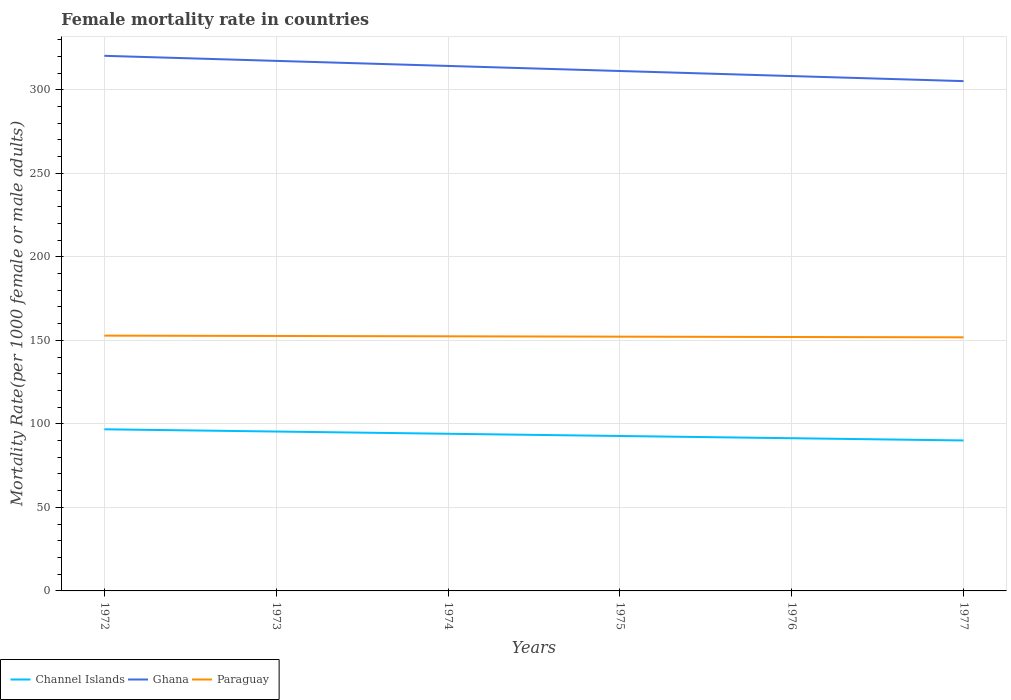Across all years, what is the maximum female mortality rate in Paraguay?
Offer a terse response. 151.8. In which year was the female mortality rate in Paraguay maximum?
Provide a short and direct response. 1977. What is the total female mortality rate in Paraguay in the graph?
Your response must be concise. 0.61. What is the difference between the highest and the second highest female mortality rate in Paraguay?
Offer a terse response. 1.02. What is the difference between the highest and the lowest female mortality rate in Channel Islands?
Provide a succinct answer. 3. How many years are there in the graph?
Provide a succinct answer. 6. How many legend labels are there?
Make the answer very short. 3. How are the legend labels stacked?
Offer a terse response. Horizontal. What is the title of the graph?
Offer a very short reply. Female mortality rate in countries. What is the label or title of the X-axis?
Provide a short and direct response. Years. What is the label or title of the Y-axis?
Keep it short and to the point. Mortality Rate(per 1000 female or male adults). What is the Mortality Rate(per 1000 female or male adults) in Channel Islands in 1972?
Offer a terse response. 96.75. What is the Mortality Rate(per 1000 female or male adults) of Ghana in 1972?
Provide a succinct answer. 320.33. What is the Mortality Rate(per 1000 female or male adults) in Paraguay in 1972?
Keep it short and to the point. 152.82. What is the Mortality Rate(per 1000 female or male adults) of Channel Islands in 1973?
Ensure brevity in your answer.  95.42. What is the Mortality Rate(per 1000 female or male adults) in Ghana in 1973?
Give a very brief answer. 317.3. What is the Mortality Rate(per 1000 female or male adults) in Paraguay in 1973?
Your response must be concise. 152.62. What is the Mortality Rate(per 1000 female or male adults) of Channel Islands in 1974?
Your answer should be very brief. 94.08. What is the Mortality Rate(per 1000 female or male adults) in Ghana in 1974?
Ensure brevity in your answer.  314.27. What is the Mortality Rate(per 1000 female or male adults) of Paraguay in 1974?
Make the answer very short. 152.42. What is the Mortality Rate(per 1000 female or male adults) in Channel Islands in 1975?
Make the answer very short. 92.75. What is the Mortality Rate(per 1000 female or male adults) of Ghana in 1975?
Your response must be concise. 311.24. What is the Mortality Rate(per 1000 female or male adults) of Paraguay in 1975?
Provide a succinct answer. 152.21. What is the Mortality Rate(per 1000 female or male adults) of Channel Islands in 1976?
Ensure brevity in your answer.  91.41. What is the Mortality Rate(per 1000 female or male adults) of Ghana in 1976?
Your answer should be compact. 308.21. What is the Mortality Rate(per 1000 female or male adults) of Paraguay in 1976?
Offer a very short reply. 152.01. What is the Mortality Rate(per 1000 female or male adults) in Channel Islands in 1977?
Make the answer very short. 90.08. What is the Mortality Rate(per 1000 female or male adults) in Ghana in 1977?
Make the answer very short. 305.18. What is the Mortality Rate(per 1000 female or male adults) in Paraguay in 1977?
Your response must be concise. 151.8. Across all years, what is the maximum Mortality Rate(per 1000 female or male adults) of Channel Islands?
Ensure brevity in your answer.  96.75. Across all years, what is the maximum Mortality Rate(per 1000 female or male adults) of Ghana?
Your answer should be compact. 320.33. Across all years, what is the maximum Mortality Rate(per 1000 female or male adults) in Paraguay?
Your answer should be compact. 152.82. Across all years, what is the minimum Mortality Rate(per 1000 female or male adults) in Channel Islands?
Offer a very short reply. 90.08. Across all years, what is the minimum Mortality Rate(per 1000 female or male adults) of Ghana?
Provide a short and direct response. 305.18. Across all years, what is the minimum Mortality Rate(per 1000 female or male adults) of Paraguay?
Offer a very short reply. 151.8. What is the total Mortality Rate(per 1000 female or male adults) of Channel Islands in the graph?
Your answer should be very brief. 560.48. What is the total Mortality Rate(per 1000 female or male adults) in Ghana in the graph?
Offer a very short reply. 1876.54. What is the total Mortality Rate(per 1000 female or male adults) in Paraguay in the graph?
Make the answer very short. 913.88. What is the difference between the Mortality Rate(per 1000 female or male adults) in Channel Islands in 1972 and that in 1973?
Make the answer very short. 1.33. What is the difference between the Mortality Rate(per 1000 female or male adults) of Ghana in 1972 and that in 1973?
Offer a terse response. 3.03. What is the difference between the Mortality Rate(per 1000 female or male adults) in Paraguay in 1972 and that in 1973?
Make the answer very short. 0.2. What is the difference between the Mortality Rate(per 1000 female or male adults) of Channel Islands in 1972 and that in 1974?
Offer a terse response. 2.67. What is the difference between the Mortality Rate(per 1000 female or male adults) of Ghana in 1972 and that in 1974?
Your answer should be compact. 6.06. What is the difference between the Mortality Rate(per 1000 female or male adults) of Paraguay in 1972 and that in 1974?
Your response must be concise. 0.41. What is the difference between the Mortality Rate(per 1000 female or male adults) of Channel Islands in 1972 and that in 1975?
Make the answer very short. 4. What is the difference between the Mortality Rate(per 1000 female or male adults) of Ghana in 1972 and that in 1975?
Provide a short and direct response. 9.09. What is the difference between the Mortality Rate(per 1000 female or male adults) of Paraguay in 1972 and that in 1975?
Your answer should be compact. 0.61. What is the difference between the Mortality Rate(per 1000 female or male adults) in Channel Islands in 1972 and that in 1976?
Offer a terse response. 5.34. What is the difference between the Mortality Rate(per 1000 female or male adults) in Ghana in 1972 and that in 1976?
Make the answer very short. 12.12. What is the difference between the Mortality Rate(per 1000 female or male adults) of Paraguay in 1972 and that in 1976?
Offer a very short reply. 0.82. What is the difference between the Mortality Rate(per 1000 female or male adults) in Channel Islands in 1972 and that in 1977?
Your answer should be very brief. 6.67. What is the difference between the Mortality Rate(per 1000 female or male adults) of Ghana in 1972 and that in 1977?
Give a very brief answer. 15.15. What is the difference between the Mortality Rate(per 1000 female or male adults) of Paraguay in 1972 and that in 1977?
Ensure brevity in your answer.  1.02. What is the difference between the Mortality Rate(per 1000 female or male adults) in Channel Islands in 1973 and that in 1974?
Your answer should be compact. 1.33. What is the difference between the Mortality Rate(per 1000 female or male adults) in Ghana in 1973 and that in 1974?
Your answer should be compact. 3.03. What is the difference between the Mortality Rate(per 1000 female or male adults) in Paraguay in 1973 and that in 1974?
Offer a very short reply. 0.2. What is the difference between the Mortality Rate(per 1000 female or male adults) of Channel Islands in 1973 and that in 1975?
Ensure brevity in your answer.  2.67. What is the difference between the Mortality Rate(per 1000 female or male adults) in Ghana in 1973 and that in 1975?
Keep it short and to the point. 6.06. What is the difference between the Mortality Rate(per 1000 female or male adults) of Paraguay in 1973 and that in 1975?
Give a very brief answer. 0.41. What is the difference between the Mortality Rate(per 1000 female or male adults) of Channel Islands in 1973 and that in 1976?
Provide a succinct answer. 4. What is the difference between the Mortality Rate(per 1000 female or male adults) of Ghana in 1973 and that in 1976?
Give a very brief answer. 9.09. What is the difference between the Mortality Rate(per 1000 female or male adults) of Paraguay in 1973 and that in 1976?
Provide a short and direct response. 0.61. What is the difference between the Mortality Rate(per 1000 female or male adults) in Channel Islands in 1973 and that in 1977?
Offer a very short reply. 5.34. What is the difference between the Mortality Rate(per 1000 female or male adults) in Ghana in 1973 and that in 1977?
Make the answer very short. 12.12. What is the difference between the Mortality Rate(per 1000 female or male adults) in Paraguay in 1973 and that in 1977?
Ensure brevity in your answer.  0.82. What is the difference between the Mortality Rate(per 1000 female or male adults) in Channel Islands in 1974 and that in 1975?
Give a very brief answer. 1.33. What is the difference between the Mortality Rate(per 1000 female or male adults) in Ghana in 1974 and that in 1975?
Make the answer very short. 3.03. What is the difference between the Mortality Rate(per 1000 female or male adults) in Paraguay in 1974 and that in 1975?
Your response must be concise. 0.2. What is the difference between the Mortality Rate(per 1000 female or male adults) of Channel Islands in 1974 and that in 1976?
Your answer should be compact. 2.67. What is the difference between the Mortality Rate(per 1000 female or male adults) in Ghana in 1974 and that in 1976?
Your answer should be compact. 6.06. What is the difference between the Mortality Rate(per 1000 female or male adults) of Paraguay in 1974 and that in 1976?
Your response must be concise. 0.41. What is the difference between the Mortality Rate(per 1000 female or male adults) in Channel Islands in 1974 and that in 1977?
Make the answer very short. 4. What is the difference between the Mortality Rate(per 1000 female or male adults) in Ghana in 1974 and that in 1977?
Keep it short and to the point. 9.09. What is the difference between the Mortality Rate(per 1000 female or male adults) of Paraguay in 1974 and that in 1977?
Provide a succinct answer. 0.61. What is the difference between the Mortality Rate(per 1000 female or male adults) of Channel Islands in 1975 and that in 1976?
Ensure brevity in your answer.  1.33. What is the difference between the Mortality Rate(per 1000 female or male adults) in Ghana in 1975 and that in 1976?
Give a very brief answer. 3.03. What is the difference between the Mortality Rate(per 1000 female or male adults) of Paraguay in 1975 and that in 1976?
Offer a very short reply. 0.2. What is the difference between the Mortality Rate(per 1000 female or male adults) in Channel Islands in 1975 and that in 1977?
Provide a short and direct response. 2.67. What is the difference between the Mortality Rate(per 1000 female or male adults) in Ghana in 1975 and that in 1977?
Offer a terse response. 6.06. What is the difference between the Mortality Rate(per 1000 female or male adults) in Paraguay in 1975 and that in 1977?
Provide a succinct answer. 0.41. What is the difference between the Mortality Rate(per 1000 female or male adults) in Channel Islands in 1976 and that in 1977?
Provide a succinct answer. 1.33. What is the difference between the Mortality Rate(per 1000 female or male adults) in Ghana in 1976 and that in 1977?
Keep it short and to the point. 3.03. What is the difference between the Mortality Rate(per 1000 female or male adults) of Paraguay in 1976 and that in 1977?
Ensure brevity in your answer.  0.2. What is the difference between the Mortality Rate(per 1000 female or male adults) in Channel Islands in 1972 and the Mortality Rate(per 1000 female or male adults) in Ghana in 1973?
Your response must be concise. -220.55. What is the difference between the Mortality Rate(per 1000 female or male adults) of Channel Islands in 1972 and the Mortality Rate(per 1000 female or male adults) of Paraguay in 1973?
Your response must be concise. -55.87. What is the difference between the Mortality Rate(per 1000 female or male adults) of Ghana in 1972 and the Mortality Rate(per 1000 female or male adults) of Paraguay in 1973?
Your answer should be very brief. 167.71. What is the difference between the Mortality Rate(per 1000 female or male adults) in Channel Islands in 1972 and the Mortality Rate(per 1000 female or male adults) in Ghana in 1974?
Ensure brevity in your answer.  -217.52. What is the difference between the Mortality Rate(per 1000 female or male adults) of Channel Islands in 1972 and the Mortality Rate(per 1000 female or male adults) of Paraguay in 1974?
Make the answer very short. -55.67. What is the difference between the Mortality Rate(per 1000 female or male adults) of Ghana in 1972 and the Mortality Rate(per 1000 female or male adults) of Paraguay in 1974?
Ensure brevity in your answer.  167.92. What is the difference between the Mortality Rate(per 1000 female or male adults) of Channel Islands in 1972 and the Mortality Rate(per 1000 female or male adults) of Ghana in 1975?
Provide a succinct answer. -214.49. What is the difference between the Mortality Rate(per 1000 female or male adults) of Channel Islands in 1972 and the Mortality Rate(per 1000 female or male adults) of Paraguay in 1975?
Ensure brevity in your answer.  -55.46. What is the difference between the Mortality Rate(per 1000 female or male adults) of Ghana in 1972 and the Mortality Rate(per 1000 female or male adults) of Paraguay in 1975?
Provide a short and direct response. 168.12. What is the difference between the Mortality Rate(per 1000 female or male adults) of Channel Islands in 1972 and the Mortality Rate(per 1000 female or male adults) of Ghana in 1976?
Offer a terse response. -211.46. What is the difference between the Mortality Rate(per 1000 female or male adults) of Channel Islands in 1972 and the Mortality Rate(per 1000 female or male adults) of Paraguay in 1976?
Ensure brevity in your answer.  -55.26. What is the difference between the Mortality Rate(per 1000 female or male adults) in Ghana in 1972 and the Mortality Rate(per 1000 female or male adults) in Paraguay in 1976?
Your response must be concise. 168.33. What is the difference between the Mortality Rate(per 1000 female or male adults) of Channel Islands in 1972 and the Mortality Rate(per 1000 female or male adults) of Ghana in 1977?
Offer a terse response. -208.43. What is the difference between the Mortality Rate(per 1000 female or male adults) of Channel Islands in 1972 and the Mortality Rate(per 1000 female or male adults) of Paraguay in 1977?
Make the answer very short. -55.05. What is the difference between the Mortality Rate(per 1000 female or male adults) of Ghana in 1972 and the Mortality Rate(per 1000 female or male adults) of Paraguay in 1977?
Offer a terse response. 168.53. What is the difference between the Mortality Rate(per 1000 female or male adults) in Channel Islands in 1973 and the Mortality Rate(per 1000 female or male adults) in Ghana in 1974?
Offer a terse response. -218.86. What is the difference between the Mortality Rate(per 1000 female or male adults) of Channel Islands in 1973 and the Mortality Rate(per 1000 female or male adults) of Paraguay in 1974?
Your response must be concise. -57. What is the difference between the Mortality Rate(per 1000 female or male adults) in Ghana in 1973 and the Mortality Rate(per 1000 female or male adults) in Paraguay in 1974?
Offer a terse response. 164.89. What is the difference between the Mortality Rate(per 1000 female or male adults) in Channel Islands in 1973 and the Mortality Rate(per 1000 female or male adults) in Ghana in 1975?
Give a very brief answer. -215.83. What is the difference between the Mortality Rate(per 1000 female or male adults) of Channel Islands in 1973 and the Mortality Rate(per 1000 female or male adults) of Paraguay in 1975?
Your answer should be compact. -56.8. What is the difference between the Mortality Rate(per 1000 female or male adults) in Ghana in 1973 and the Mortality Rate(per 1000 female or male adults) in Paraguay in 1975?
Your answer should be very brief. 165.09. What is the difference between the Mortality Rate(per 1000 female or male adults) in Channel Islands in 1973 and the Mortality Rate(per 1000 female or male adults) in Ghana in 1976?
Make the answer very short. -212.8. What is the difference between the Mortality Rate(per 1000 female or male adults) in Channel Islands in 1973 and the Mortality Rate(per 1000 female or male adults) in Paraguay in 1976?
Your response must be concise. -56.59. What is the difference between the Mortality Rate(per 1000 female or male adults) in Ghana in 1973 and the Mortality Rate(per 1000 female or male adults) in Paraguay in 1976?
Your answer should be compact. 165.3. What is the difference between the Mortality Rate(per 1000 female or male adults) of Channel Islands in 1973 and the Mortality Rate(per 1000 female or male adults) of Ghana in 1977?
Offer a terse response. -209.76. What is the difference between the Mortality Rate(per 1000 female or male adults) in Channel Islands in 1973 and the Mortality Rate(per 1000 female or male adults) in Paraguay in 1977?
Your response must be concise. -56.39. What is the difference between the Mortality Rate(per 1000 female or male adults) in Ghana in 1973 and the Mortality Rate(per 1000 female or male adults) in Paraguay in 1977?
Provide a short and direct response. 165.5. What is the difference between the Mortality Rate(per 1000 female or male adults) in Channel Islands in 1974 and the Mortality Rate(per 1000 female or male adults) in Ghana in 1975?
Provide a succinct answer. -217.16. What is the difference between the Mortality Rate(per 1000 female or male adults) in Channel Islands in 1974 and the Mortality Rate(per 1000 female or male adults) in Paraguay in 1975?
Ensure brevity in your answer.  -58.13. What is the difference between the Mortality Rate(per 1000 female or male adults) of Ghana in 1974 and the Mortality Rate(per 1000 female or male adults) of Paraguay in 1975?
Provide a succinct answer. 162.06. What is the difference between the Mortality Rate(per 1000 female or male adults) of Channel Islands in 1974 and the Mortality Rate(per 1000 female or male adults) of Ghana in 1976?
Your answer should be very brief. -214.13. What is the difference between the Mortality Rate(per 1000 female or male adults) in Channel Islands in 1974 and the Mortality Rate(per 1000 female or male adults) in Paraguay in 1976?
Your answer should be compact. -57.93. What is the difference between the Mortality Rate(per 1000 female or male adults) in Ghana in 1974 and the Mortality Rate(per 1000 female or male adults) in Paraguay in 1976?
Your response must be concise. 162.26. What is the difference between the Mortality Rate(per 1000 female or male adults) of Channel Islands in 1974 and the Mortality Rate(per 1000 female or male adults) of Ghana in 1977?
Make the answer very short. -211.1. What is the difference between the Mortality Rate(per 1000 female or male adults) in Channel Islands in 1974 and the Mortality Rate(per 1000 female or male adults) in Paraguay in 1977?
Make the answer very short. -57.72. What is the difference between the Mortality Rate(per 1000 female or male adults) in Ghana in 1974 and the Mortality Rate(per 1000 female or male adults) in Paraguay in 1977?
Ensure brevity in your answer.  162.47. What is the difference between the Mortality Rate(per 1000 female or male adults) in Channel Islands in 1975 and the Mortality Rate(per 1000 female or male adults) in Ghana in 1976?
Provide a short and direct response. -215.47. What is the difference between the Mortality Rate(per 1000 female or male adults) of Channel Islands in 1975 and the Mortality Rate(per 1000 female or male adults) of Paraguay in 1976?
Make the answer very short. -59.26. What is the difference between the Mortality Rate(per 1000 female or male adults) in Ghana in 1975 and the Mortality Rate(per 1000 female or male adults) in Paraguay in 1976?
Provide a succinct answer. 159.23. What is the difference between the Mortality Rate(per 1000 female or male adults) of Channel Islands in 1975 and the Mortality Rate(per 1000 female or male adults) of Ghana in 1977?
Ensure brevity in your answer.  -212.44. What is the difference between the Mortality Rate(per 1000 female or male adults) in Channel Islands in 1975 and the Mortality Rate(per 1000 female or male adults) in Paraguay in 1977?
Offer a terse response. -59.06. What is the difference between the Mortality Rate(per 1000 female or male adults) of Ghana in 1975 and the Mortality Rate(per 1000 female or male adults) of Paraguay in 1977?
Give a very brief answer. 159.44. What is the difference between the Mortality Rate(per 1000 female or male adults) in Channel Islands in 1976 and the Mortality Rate(per 1000 female or male adults) in Ghana in 1977?
Keep it short and to the point. -213.77. What is the difference between the Mortality Rate(per 1000 female or male adults) of Channel Islands in 1976 and the Mortality Rate(per 1000 female or male adults) of Paraguay in 1977?
Your answer should be very brief. -60.39. What is the difference between the Mortality Rate(per 1000 female or male adults) in Ghana in 1976 and the Mortality Rate(per 1000 female or male adults) in Paraguay in 1977?
Keep it short and to the point. 156.41. What is the average Mortality Rate(per 1000 female or male adults) in Channel Islands per year?
Your answer should be compact. 93.41. What is the average Mortality Rate(per 1000 female or male adults) of Ghana per year?
Ensure brevity in your answer.  312.76. What is the average Mortality Rate(per 1000 female or male adults) of Paraguay per year?
Ensure brevity in your answer.  152.31. In the year 1972, what is the difference between the Mortality Rate(per 1000 female or male adults) in Channel Islands and Mortality Rate(per 1000 female or male adults) in Ghana?
Keep it short and to the point. -223.58. In the year 1972, what is the difference between the Mortality Rate(per 1000 female or male adults) in Channel Islands and Mortality Rate(per 1000 female or male adults) in Paraguay?
Your answer should be compact. -56.07. In the year 1972, what is the difference between the Mortality Rate(per 1000 female or male adults) in Ghana and Mortality Rate(per 1000 female or male adults) in Paraguay?
Your answer should be compact. 167.51. In the year 1973, what is the difference between the Mortality Rate(per 1000 female or male adults) of Channel Islands and Mortality Rate(per 1000 female or male adults) of Ghana?
Provide a succinct answer. -221.89. In the year 1973, what is the difference between the Mortality Rate(per 1000 female or male adults) of Channel Islands and Mortality Rate(per 1000 female or male adults) of Paraguay?
Offer a very short reply. -57.2. In the year 1973, what is the difference between the Mortality Rate(per 1000 female or male adults) of Ghana and Mortality Rate(per 1000 female or male adults) of Paraguay?
Ensure brevity in your answer.  164.68. In the year 1974, what is the difference between the Mortality Rate(per 1000 female or male adults) in Channel Islands and Mortality Rate(per 1000 female or male adults) in Ghana?
Keep it short and to the point. -220.19. In the year 1974, what is the difference between the Mortality Rate(per 1000 female or male adults) in Channel Islands and Mortality Rate(per 1000 female or male adults) in Paraguay?
Provide a succinct answer. -58.34. In the year 1974, what is the difference between the Mortality Rate(per 1000 female or male adults) of Ghana and Mortality Rate(per 1000 female or male adults) of Paraguay?
Ensure brevity in your answer.  161.86. In the year 1975, what is the difference between the Mortality Rate(per 1000 female or male adults) in Channel Islands and Mortality Rate(per 1000 female or male adults) in Ghana?
Your answer should be very brief. -218.5. In the year 1975, what is the difference between the Mortality Rate(per 1000 female or male adults) of Channel Islands and Mortality Rate(per 1000 female or male adults) of Paraguay?
Your response must be concise. -59.47. In the year 1975, what is the difference between the Mortality Rate(per 1000 female or male adults) in Ghana and Mortality Rate(per 1000 female or male adults) in Paraguay?
Offer a very short reply. 159.03. In the year 1976, what is the difference between the Mortality Rate(per 1000 female or male adults) in Channel Islands and Mortality Rate(per 1000 female or male adults) in Ghana?
Provide a short and direct response. -216.8. In the year 1976, what is the difference between the Mortality Rate(per 1000 female or male adults) in Channel Islands and Mortality Rate(per 1000 female or male adults) in Paraguay?
Provide a short and direct response. -60.6. In the year 1976, what is the difference between the Mortality Rate(per 1000 female or male adults) in Ghana and Mortality Rate(per 1000 female or male adults) in Paraguay?
Your response must be concise. 156.2. In the year 1977, what is the difference between the Mortality Rate(per 1000 female or male adults) in Channel Islands and Mortality Rate(per 1000 female or male adults) in Ghana?
Make the answer very short. -215.1. In the year 1977, what is the difference between the Mortality Rate(per 1000 female or male adults) in Channel Islands and Mortality Rate(per 1000 female or male adults) in Paraguay?
Your answer should be very brief. -61.73. In the year 1977, what is the difference between the Mortality Rate(per 1000 female or male adults) of Ghana and Mortality Rate(per 1000 female or male adults) of Paraguay?
Your answer should be very brief. 153.38. What is the ratio of the Mortality Rate(per 1000 female or male adults) in Channel Islands in 1972 to that in 1973?
Offer a terse response. 1.01. What is the ratio of the Mortality Rate(per 1000 female or male adults) in Ghana in 1972 to that in 1973?
Give a very brief answer. 1.01. What is the ratio of the Mortality Rate(per 1000 female or male adults) of Channel Islands in 1972 to that in 1974?
Ensure brevity in your answer.  1.03. What is the ratio of the Mortality Rate(per 1000 female or male adults) of Ghana in 1972 to that in 1974?
Make the answer very short. 1.02. What is the ratio of the Mortality Rate(per 1000 female or male adults) in Paraguay in 1972 to that in 1974?
Offer a very short reply. 1. What is the ratio of the Mortality Rate(per 1000 female or male adults) of Channel Islands in 1972 to that in 1975?
Your response must be concise. 1.04. What is the ratio of the Mortality Rate(per 1000 female or male adults) in Ghana in 1972 to that in 1975?
Ensure brevity in your answer.  1.03. What is the ratio of the Mortality Rate(per 1000 female or male adults) in Paraguay in 1972 to that in 1975?
Offer a terse response. 1. What is the ratio of the Mortality Rate(per 1000 female or male adults) of Channel Islands in 1972 to that in 1976?
Your answer should be very brief. 1.06. What is the ratio of the Mortality Rate(per 1000 female or male adults) of Ghana in 1972 to that in 1976?
Keep it short and to the point. 1.04. What is the ratio of the Mortality Rate(per 1000 female or male adults) of Paraguay in 1972 to that in 1976?
Your answer should be very brief. 1.01. What is the ratio of the Mortality Rate(per 1000 female or male adults) of Channel Islands in 1972 to that in 1977?
Provide a succinct answer. 1.07. What is the ratio of the Mortality Rate(per 1000 female or male adults) of Ghana in 1972 to that in 1977?
Your answer should be compact. 1.05. What is the ratio of the Mortality Rate(per 1000 female or male adults) in Channel Islands in 1973 to that in 1974?
Make the answer very short. 1.01. What is the ratio of the Mortality Rate(per 1000 female or male adults) in Ghana in 1973 to that in 1974?
Give a very brief answer. 1.01. What is the ratio of the Mortality Rate(per 1000 female or male adults) in Channel Islands in 1973 to that in 1975?
Your answer should be compact. 1.03. What is the ratio of the Mortality Rate(per 1000 female or male adults) in Ghana in 1973 to that in 1975?
Keep it short and to the point. 1.02. What is the ratio of the Mortality Rate(per 1000 female or male adults) in Channel Islands in 1973 to that in 1976?
Provide a short and direct response. 1.04. What is the ratio of the Mortality Rate(per 1000 female or male adults) of Ghana in 1973 to that in 1976?
Your response must be concise. 1.03. What is the ratio of the Mortality Rate(per 1000 female or male adults) of Paraguay in 1973 to that in 1976?
Offer a very short reply. 1. What is the ratio of the Mortality Rate(per 1000 female or male adults) of Channel Islands in 1973 to that in 1977?
Ensure brevity in your answer.  1.06. What is the ratio of the Mortality Rate(per 1000 female or male adults) of Ghana in 1973 to that in 1977?
Offer a terse response. 1.04. What is the ratio of the Mortality Rate(per 1000 female or male adults) in Paraguay in 1973 to that in 1977?
Your answer should be very brief. 1.01. What is the ratio of the Mortality Rate(per 1000 female or male adults) in Channel Islands in 1974 to that in 1975?
Keep it short and to the point. 1.01. What is the ratio of the Mortality Rate(per 1000 female or male adults) in Ghana in 1974 to that in 1975?
Provide a short and direct response. 1.01. What is the ratio of the Mortality Rate(per 1000 female or male adults) of Channel Islands in 1974 to that in 1976?
Provide a short and direct response. 1.03. What is the ratio of the Mortality Rate(per 1000 female or male adults) of Ghana in 1974 to that in 1976?
Your response must be concise. 1.02. What is the ratio of the Mortality Rate(per 1000 female or male adults) in Paraguay in 1974 to that in 1976?
Give a very brief answer. 1. What is the ratio of the Mortality Rate(per 1000 female or male adults) of Channel Islands in 1974 to that in 1977?
Your response must be concise. 1.04. What is the ratio of the Mortality Rate(per 1000 female or male adults) of Ghana in 1974 to that in 1977?
Make the answer very short. 1.03. What is the ratio of the Mortality Rate(per 1000 female or male adults) in Paraguay in 1974 to that in 1977?
Provide a succinct answer. 1. What is the ratio of the Mortality Rate(per 1000 female or male adults) of Channel Islands in 1975 to that in 1976?
Your response must be concise. 1.01. What is the ratio of the Mortality Rate(per 1000 female or male adults) in Ghana in 1975 to that in 1976?
Offer a terse response. 1.01. What is the ratio of the Mortality Rate(per 1000 female or male adults) in Channel Islands in 1975 to that in 1977?
Give a very brief answer. 1.03. What is the ratio of the Mortality Rate(per 1000 female or male adults) in Ghana in 1975 to that in 1977?
Your answer should be very brief. 1.02. What is the ratio of the Mortality Rate(per 1000 female or male adults) in Channel Islands in 1976 to that in 1977?
Your answer should be very brief. 1.01. What is the ratio of the Mortality Rate(per 1000 female or male adults) in Ghana in 1976 to that in 1977?
Provide a succinct answer. 1.01. What is the difference between the highest and the second highest Mortality Rate(per 1000 female or male adults) in Channel Islands?
Provide a short and direct response. 1.33. What is the difference between the highest and the second highest Mortality Rate(per 1000 female or male adults) in Ghana?
Your answer should be very brief. 3.03. What is the difference between the highest and the second highest Mortality Rate(per 1000 female or male adults) in Paraguay?
Your answer should be compact. 0.2. What is the difference between the highest and the lowest Mortality Rate(per 1000 female or male adults) of Channel Islands?
Your response must be concise. 6.67. What is the difference between the highest and the lowest Mortality Rate(per 1000 female or male adults) of Ghana?
Your response must be concise. 15.15. What is the difference between the highest and the lowest Mortality Rate(per 1000 female or male adults) of Paraguay?
Give a very brief answer. 1.02. 